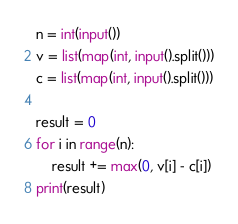<code> <loc_0><loc_0><loc_500><loc_500><_Python_>n = int(input())
v = list(map(int, input().split()))
c = list(map(int, input().split()))

result = 0
for i in range(n):
    result += max(0, v[i] - c[i])
print(result)</code> 